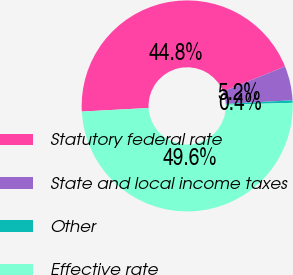Convert chart. <chart><loc_0><loc_0><loc_500><loc_500><pie_chart><fcel>Statutory federal rate<fcel>State and local income taxes<fcel>Other<fcel>Effective rate<nl><fcel>44.75%<fcel>5.25%<fcel>0.38%<fcel>49.62%<nl></chart> 